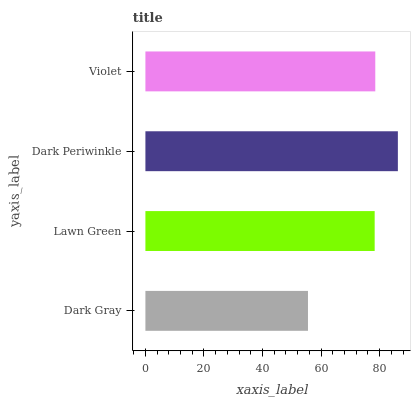Is Dark Gray the minimum?
Answer yes or no. Yes. Is Dark Periwinkle the maximum?
Answer yes or no. Yes. Is Lawn Green the minimum?
Answer yes or no. No. Is Lawn Green the maximum?
Answer yes or no. No. Is Lawn Green greater than Dark Gray?
Answer yes or no. Yes. Is Dark Gray less than Lawn Green?
Answer yes or no. Yes. Is Dark Gray greater than Lawn Green?
Answer yes or no. No. Is Lawn Green less than Dark Gray?
Answer yes or no. No. Is Violet the high median?
Answer yes or no. Yes. Is Lawn Green the low median?
Answer yes or no. Yes. Is Dark Gray the high median?
Answer yes or no. No. Is Dark Gray the low median?
Answer yes or no. No. 